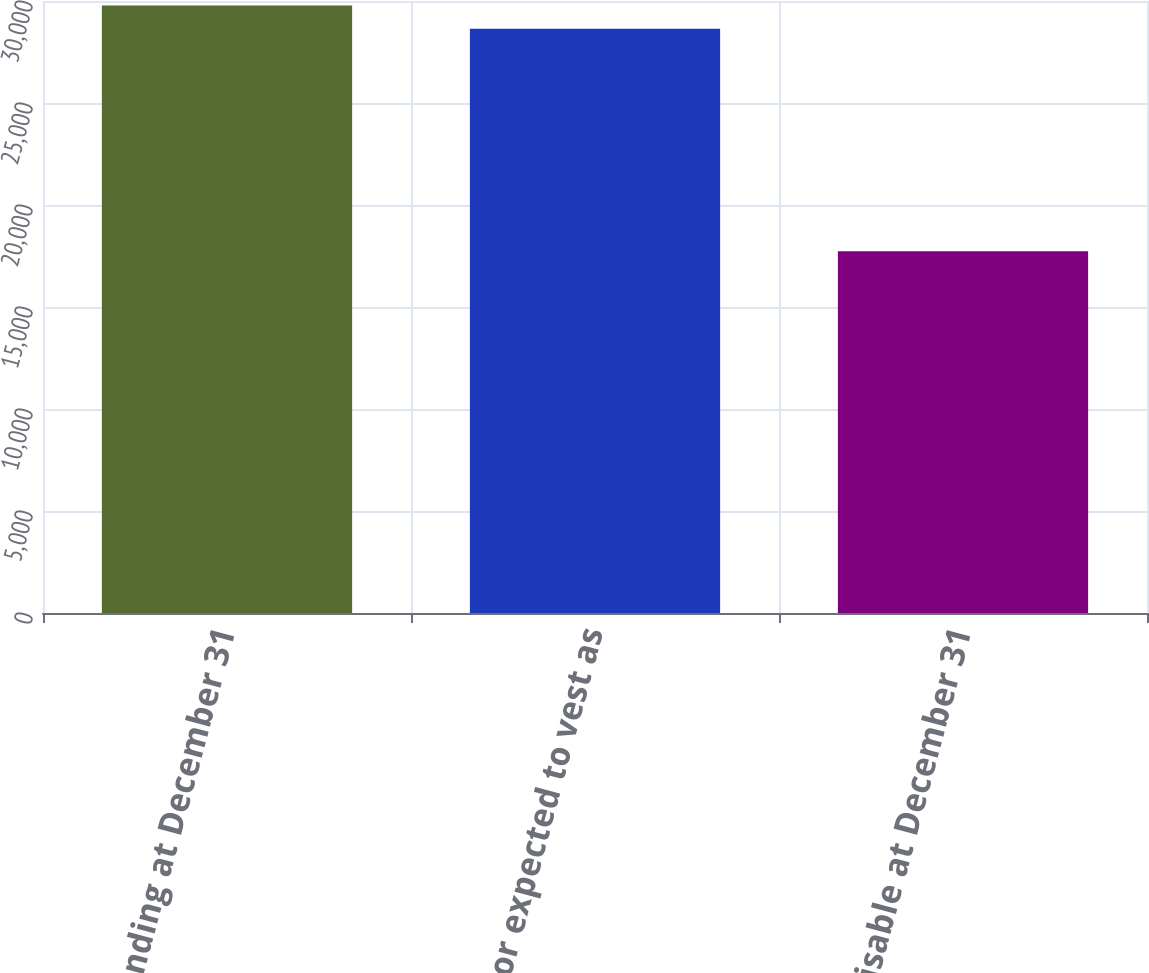Convert chart to OTSL. <chart><loc_0><loc_0><loc_500><loc_500><bar_chart><fcel>Outstanding at December 31<fcel>Vested or expected to vest as<fcel>Exercisable at December 31<nl><fcel>29781.7<fcel>28642<fcel>17732<nl></chart> 